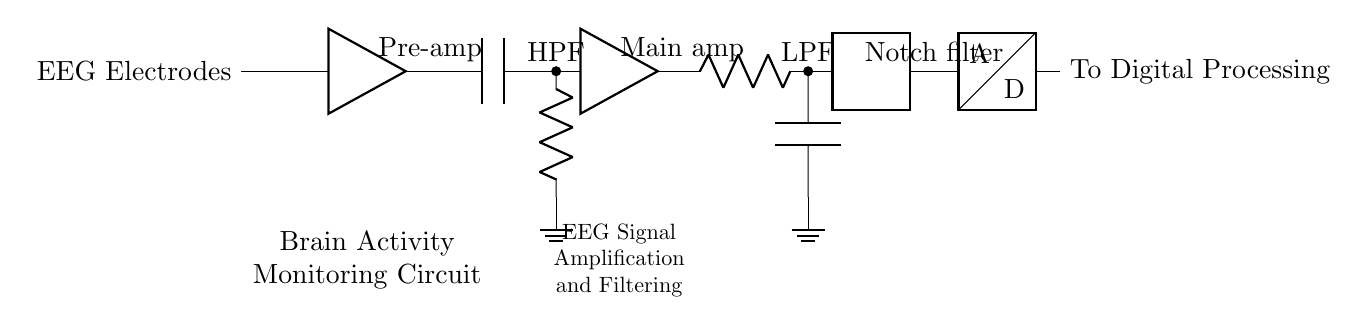What component precedes the main amplifier? The component that comes before the main amplifier in the circuit is the high-pass filter. It is connected directly to the output of the pre-amplifier.
Answer: High-pass filter What is the role of the notch filter? The notch filter is designed to eliminate specific frequency interference, particularly from power line noise at 50/60 Hz, thus improving the quality of the EEG signals.
Answer: To eliminate noise How many filters are present in this circuit? The circuit includes three filters: a high-pass filter, a low-pass filter, and a notch filter, each serving a specific function in signal processing.
Answer: Three filters What type of components are used for amplification in this circuit? The circuit contains two amplifiers: a pre-amplifier and a main amplifier which are responsible for increasing the amplitude of the EEG signals for better analysis.
Answer: Amplifiers What does the circuit ultimately connect to after processing? After processing the signals through various stages, the circuit connects to an Analog-to-Digital Converter (ADC), which digitizes the analog signals for digital processing.
Answer: To Digital Processing Explain the purpose of the high-pass filter in this circuit. The high-pass filter in this circuit allows high-frequency brain activity signals to pass while blocking lower-frequency signals, such as muscle or other noise signals, which helps isolate brain activity.
Answer: To isolate brain signals 